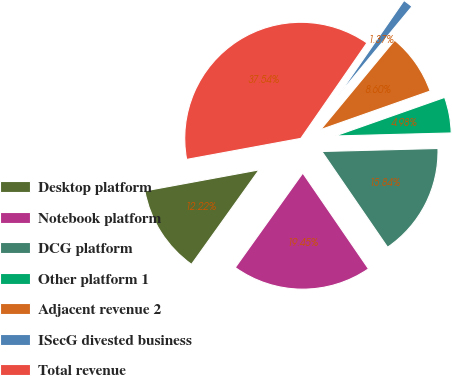<chart> <loc_0><loc_0><loc_500><loc_500><pie_chart><fcel>Desktop platform<fcel>Notebook platform<fcel>DCG platform<fcel>Other platform 1<fcel>Adjacent revenue 2<fcel>ISecG divested business<fcel>Total revenue<nl><fcel>12.22%<fcel>19.45%<fcel>15.84%<fcel>4.98%<fcel>8.6%<fcel>1.37%<fcel>37.54%<nl></chart> 